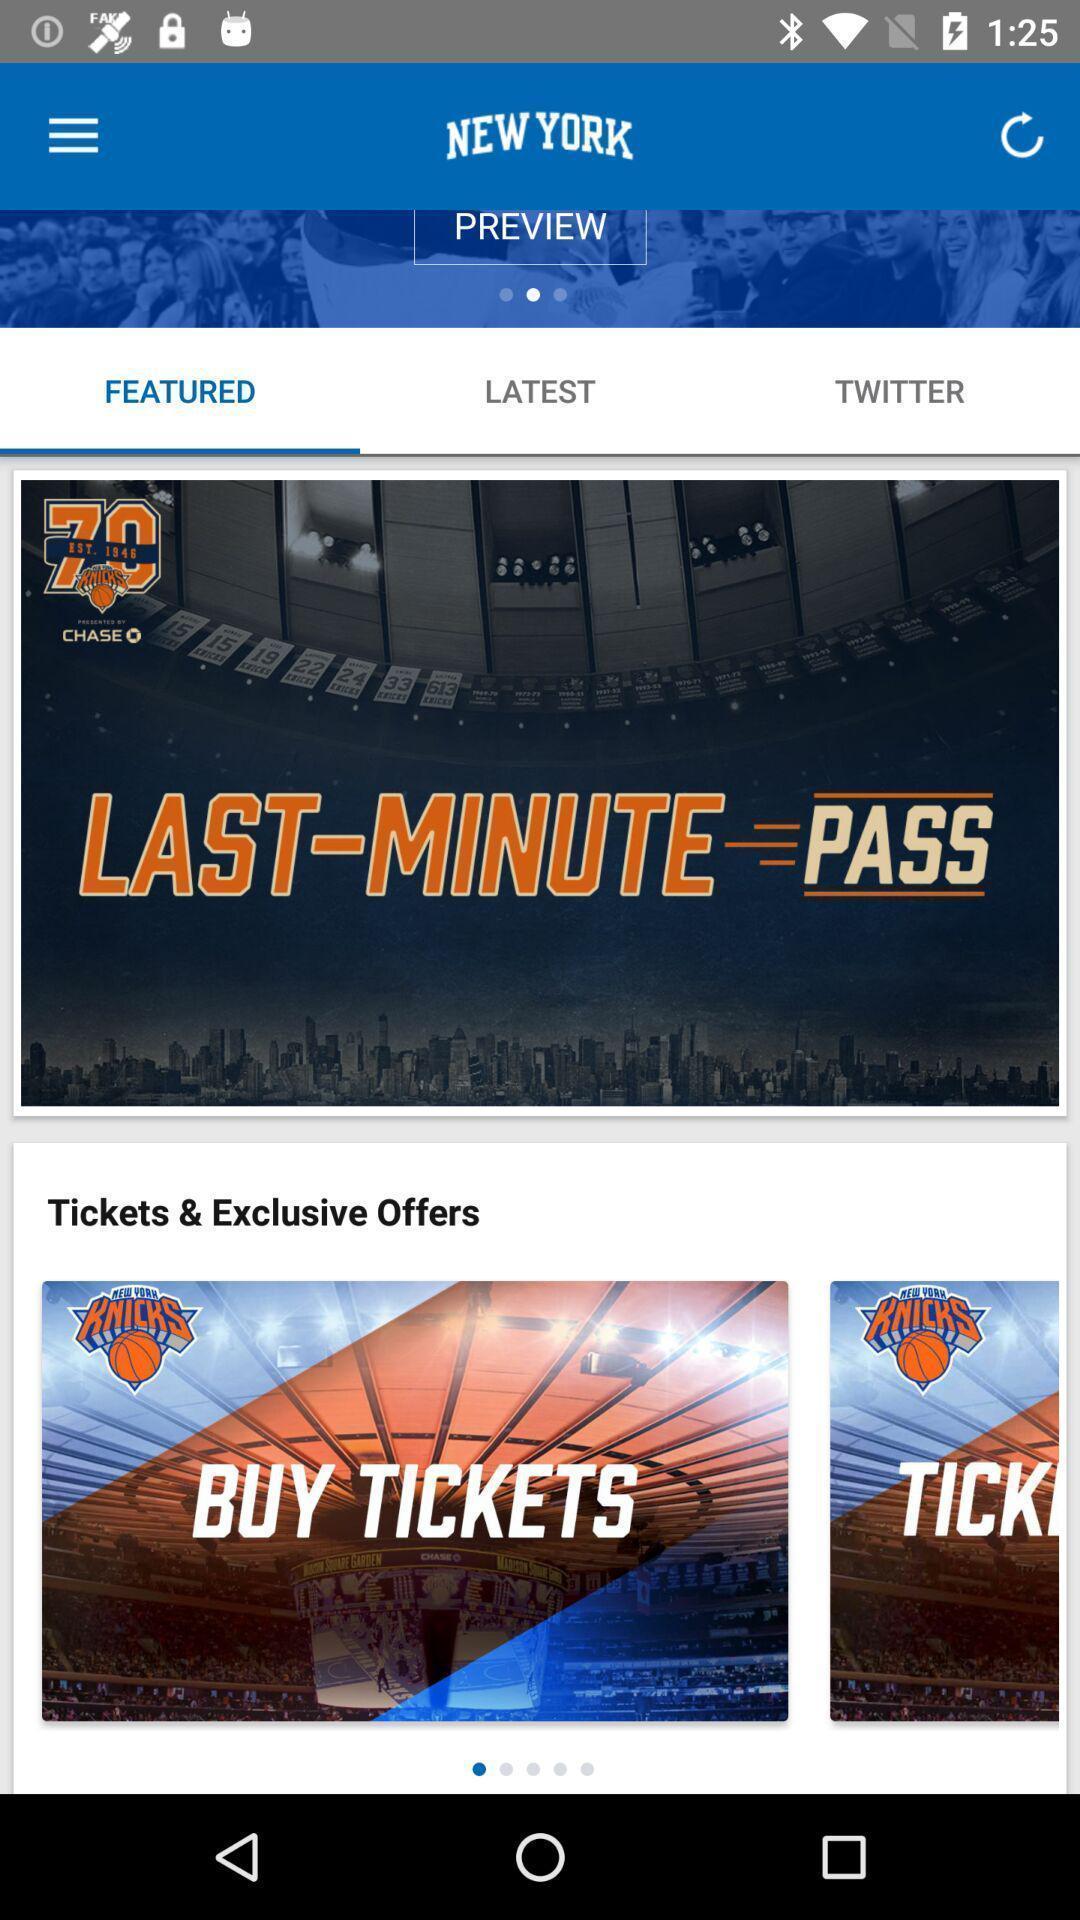Tell me about the visual elements in this screen capture. Page showing the thumbnails in featured tab. 